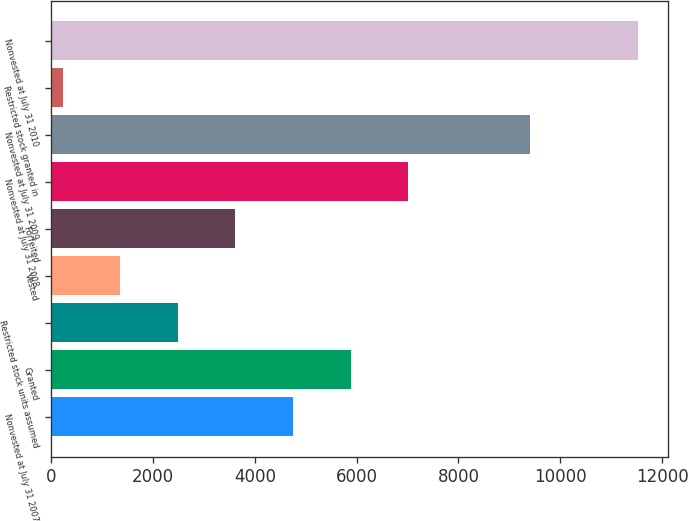Convert chart to OTSL. <chart><loc_0><loc_0><loc_500><loc_500><bar_chart><fcel>Nonvested at July 31 2007<fcel>Granted<fcel>Restricted stock units assumed<fcel>Vested<fcel>Forfeited<fcel>Nonvested at July 31 2008<fcel>Nonvested at July 31 2009<fcel>Restricted stock granted in<fcel>Nonvested at July 31 2010<nl><fcel>4751<fcel>5881<fcel>2491<fcel>1361<fcel>3621<fcel>7011<fcel>9398<fcel>231<fcel>11531<nl></chart> 